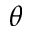Convert formula to latex. <formula><loc_0><loc_0><loc_500><loc_500>\theta</formula> 